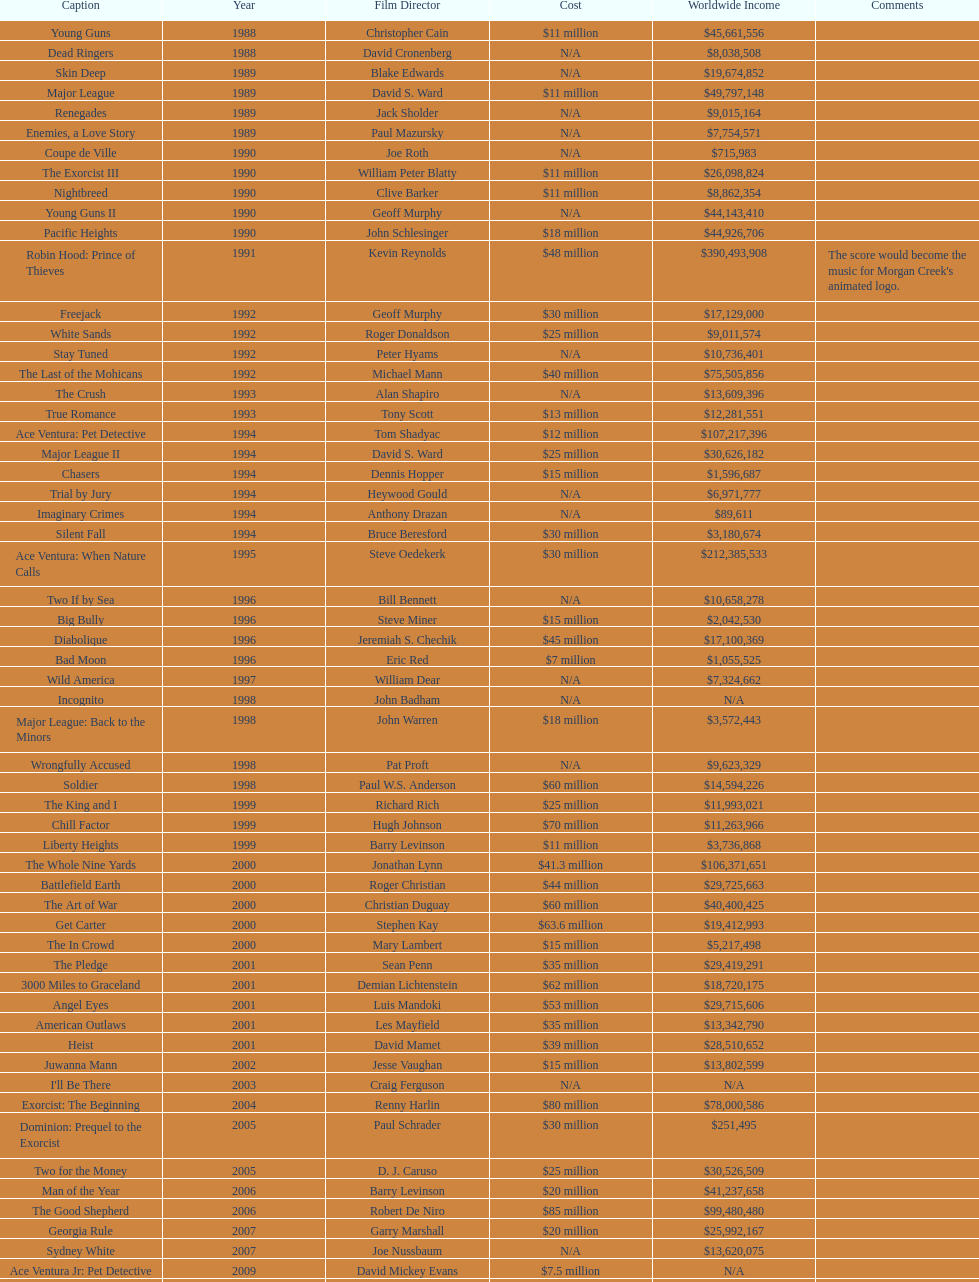Which film had a higher budget, ace ventura: when nature calls, or major league: back to the minors? Ace Ventura: When Nature Calls. 